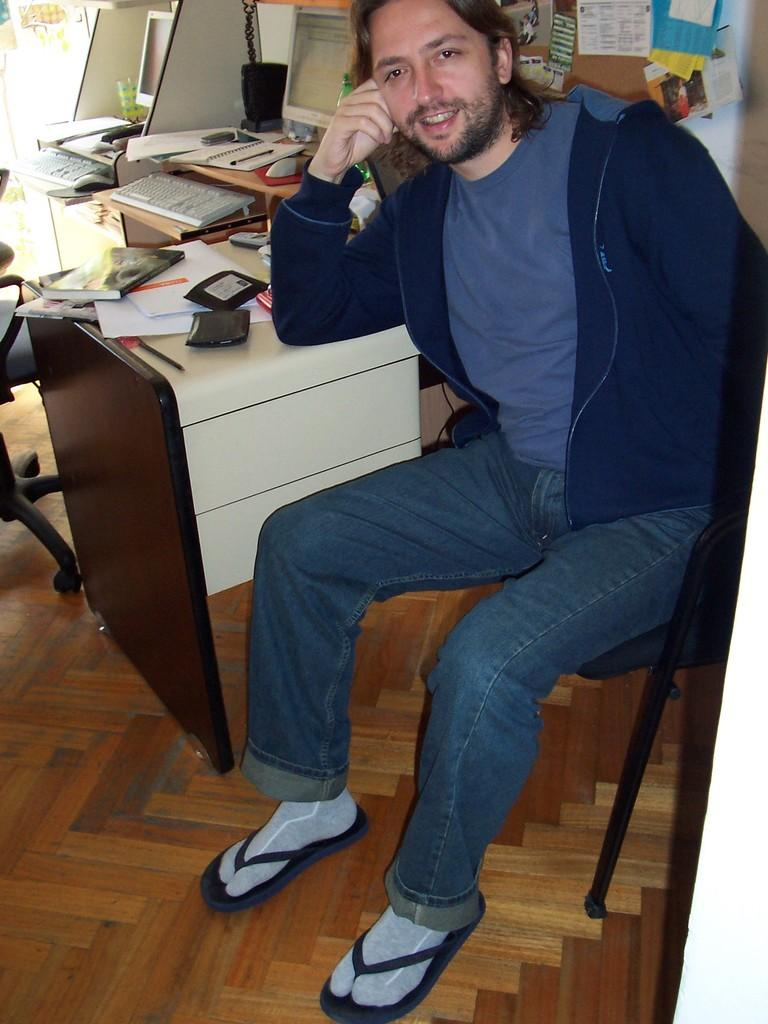What is the person in the image doing? The person is sitting on a chair in the image. Where is the person located in the image? The person is on the right side of the image. What expression does the person have? The person is smiling in the image. What type of furniture is in the image? There is a wooden table in the image. What electronic device is on the table? A computer is present on the table. What is used for typing on the computer? A keyboard is on the table. What else can be seen on the table besides the computer and keyboard? There are books on the table. How many brothers are visible in the image? There are no brothers present in the image. What type of dogs can be seen playing with the books on the table? There are no dogs present in the image, and the books are not being played with. 